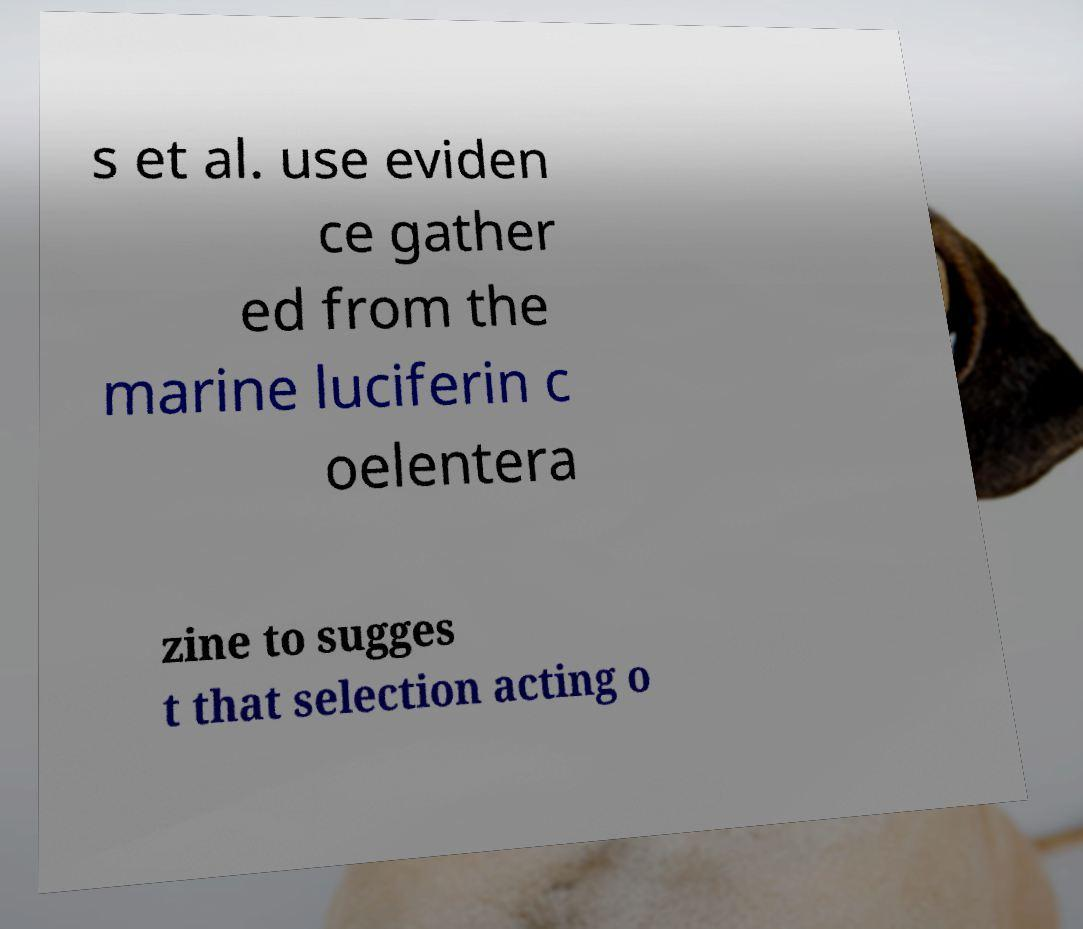Please read and relay the text visible in this image. What does it say? s et al. use eviden ce gather ed from the marine luciferin c oelentera zine to sugges t that selection acting o 